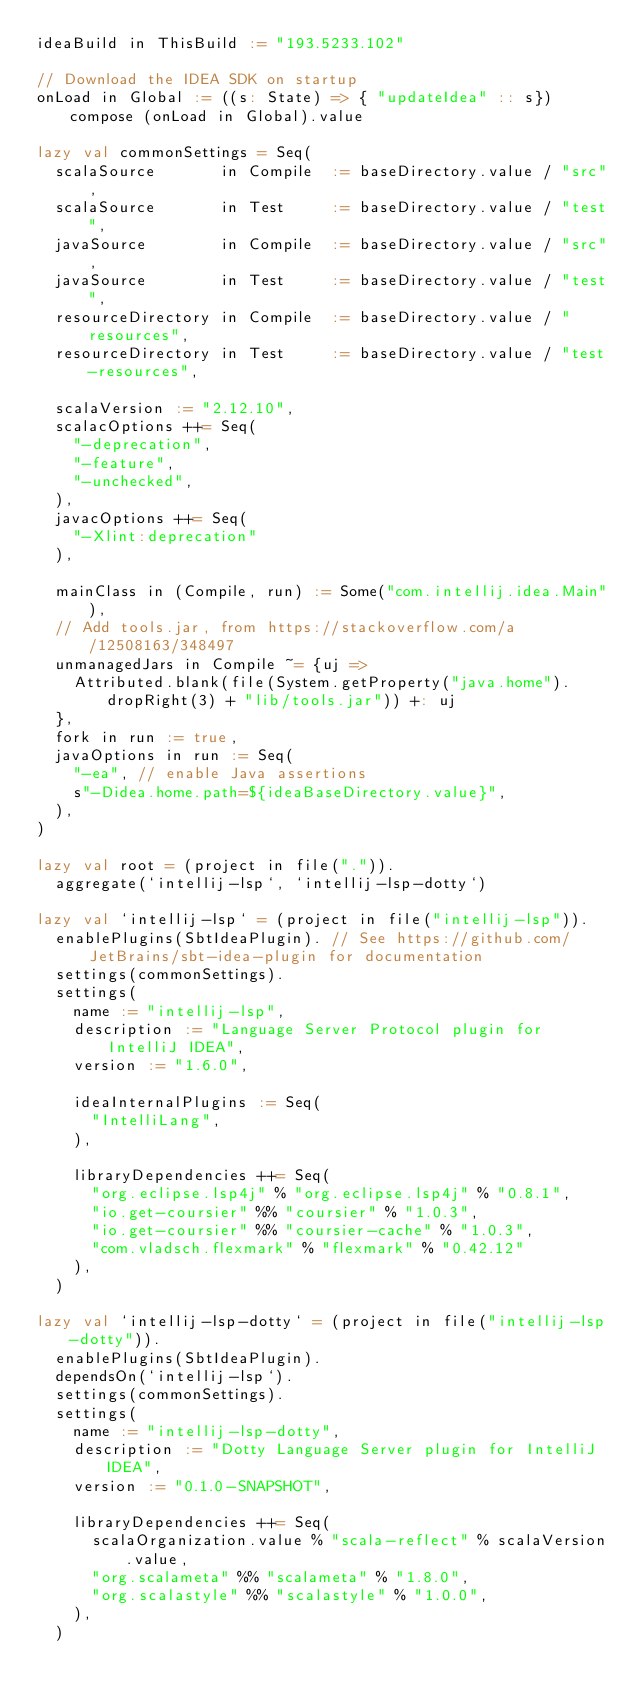Convert code to text. <code><loc_0><loc_0><loc_500><loc_500><_Scala_>ideaBuild in ThisBuild := "193.5233.102"

// Download the IDEA SDK on startup
onLoad in Global := ((s: State) => { "updateIdea" :: s}) compose (onLoad in Global).value

lazy val commonSettings = Seq(
  scalaSource       in Compile  := baseDirectory.value / "src",
  scalaSource       in Test     := baseDirectory.value / "test",
  javaSource        in Compile  := baseDirectory.value / "src",
  javaSource        in Test     := baseDirectory.value / "test",
  resourceDirectory in Compile  := baseDirectory.value / "resources",
  resourceDirectory in Test     := baseDirectory.value / "test-resources",

  scalaVersion := "2.12.10",
  scalacOptions ++= Seq(
    "-deprecation",
    "-feature",
    "-unchecked",
  ),
  javacOptions ++= Seq(
    "-Xlint:deprecation"
  ),

  mainClass in (Compile, run) := Some("com.intellij.idea.Main"),
  // Add tools.jar, from https://stackoverflow.com/a/12508163/348497
  unmanagedJars in Compile ~= {uj =>
    Attributed.blank(file(System.getProperty("java.home").dropRight(3) + "lib/tools.jar")) +: uj
  },
  fork in run := true,
  javaOptions in run := Seq(
    "-ea", // enable Java assertions
    s"-Didea.home.path=${ideaBaseDirectory.value}",
  ),
)

lazy val root = (project in file(".")).
  aggregate(`intellij-lsp`, `intellij-lsp-dotty`)

lazy val `intellij-lsp` = (project in file("intellij-lsp")).
  enablePlugins(SbtIdeaPlugin). // See https://github.com/JetBrains/sbt-idea-plugin for documentation
  settings(commonSettings).
  settings(
    name := "intellij-lsp",
    description := "Language Server Protocol plugin for IntelliJ IDEA",
    version := "1.6.0",

    ideaInternalPlugins := Seq(
      "IntelliLang",
    ),

    libraryDependencies ++= Seq(
      "org.eclipse.lsp4j" % "org.eclipse.lsp4j" % "0.8.1",
      "io.get-coursier" %% "coursier" % "1.0.3",
      "io.get-coursier" %% "coursier-cache" % "1.0.3",
      "com.vladsch.flexmark" % "flexmark" % "0.42.12"
    ),
  )

lazy val `intellij-lsp-dotty` = (project in file("intellij-lsp-dotty")).
  enablePlugins(SbtIdeaPlugin).
  dependsOn(`intellij-lsp`).
  settings(commonSettings).
  settings(
    name := "intellij-lsp-dotty",
    description := "Dotty Language Server plugin for IntelliJ IDEA",
    version := "0.1.0-SNAPSHOT",

    libraryDependencies ++= Seq(
      scalaOrganization.value % "scala-reflect" % scalaVersion.value,
      "org.scalameta" %% "scalameta" % "1.8.0",
      "org.scalastyle" %% "scalastyle" % "1.0.0",
    ),
  )
</code> 